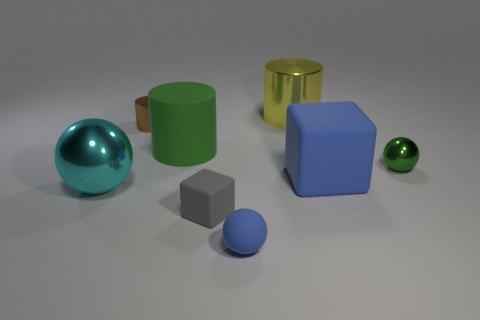Subtract all big cylinders. How many cylinders are left? 1 Subtract 1 cylinders. How many cylinders are left? 2 Add 2 small green matte cylinders. How many objects exist? 10 Subtract all balls. How many objects are left? 5 Subtract all purple cylinders. Subtract all brown spheres. How many cylinders are left? 3 Subtract all large metal cylinders. Subtract all red cubes. How many objects are left? 7 Add 6 tiny brown objects. How many tiny brown objects are left? 7 Add 1 green objects. How many green objects exist? 3 Subtract 0 brown balls. How many objects are left? 8 